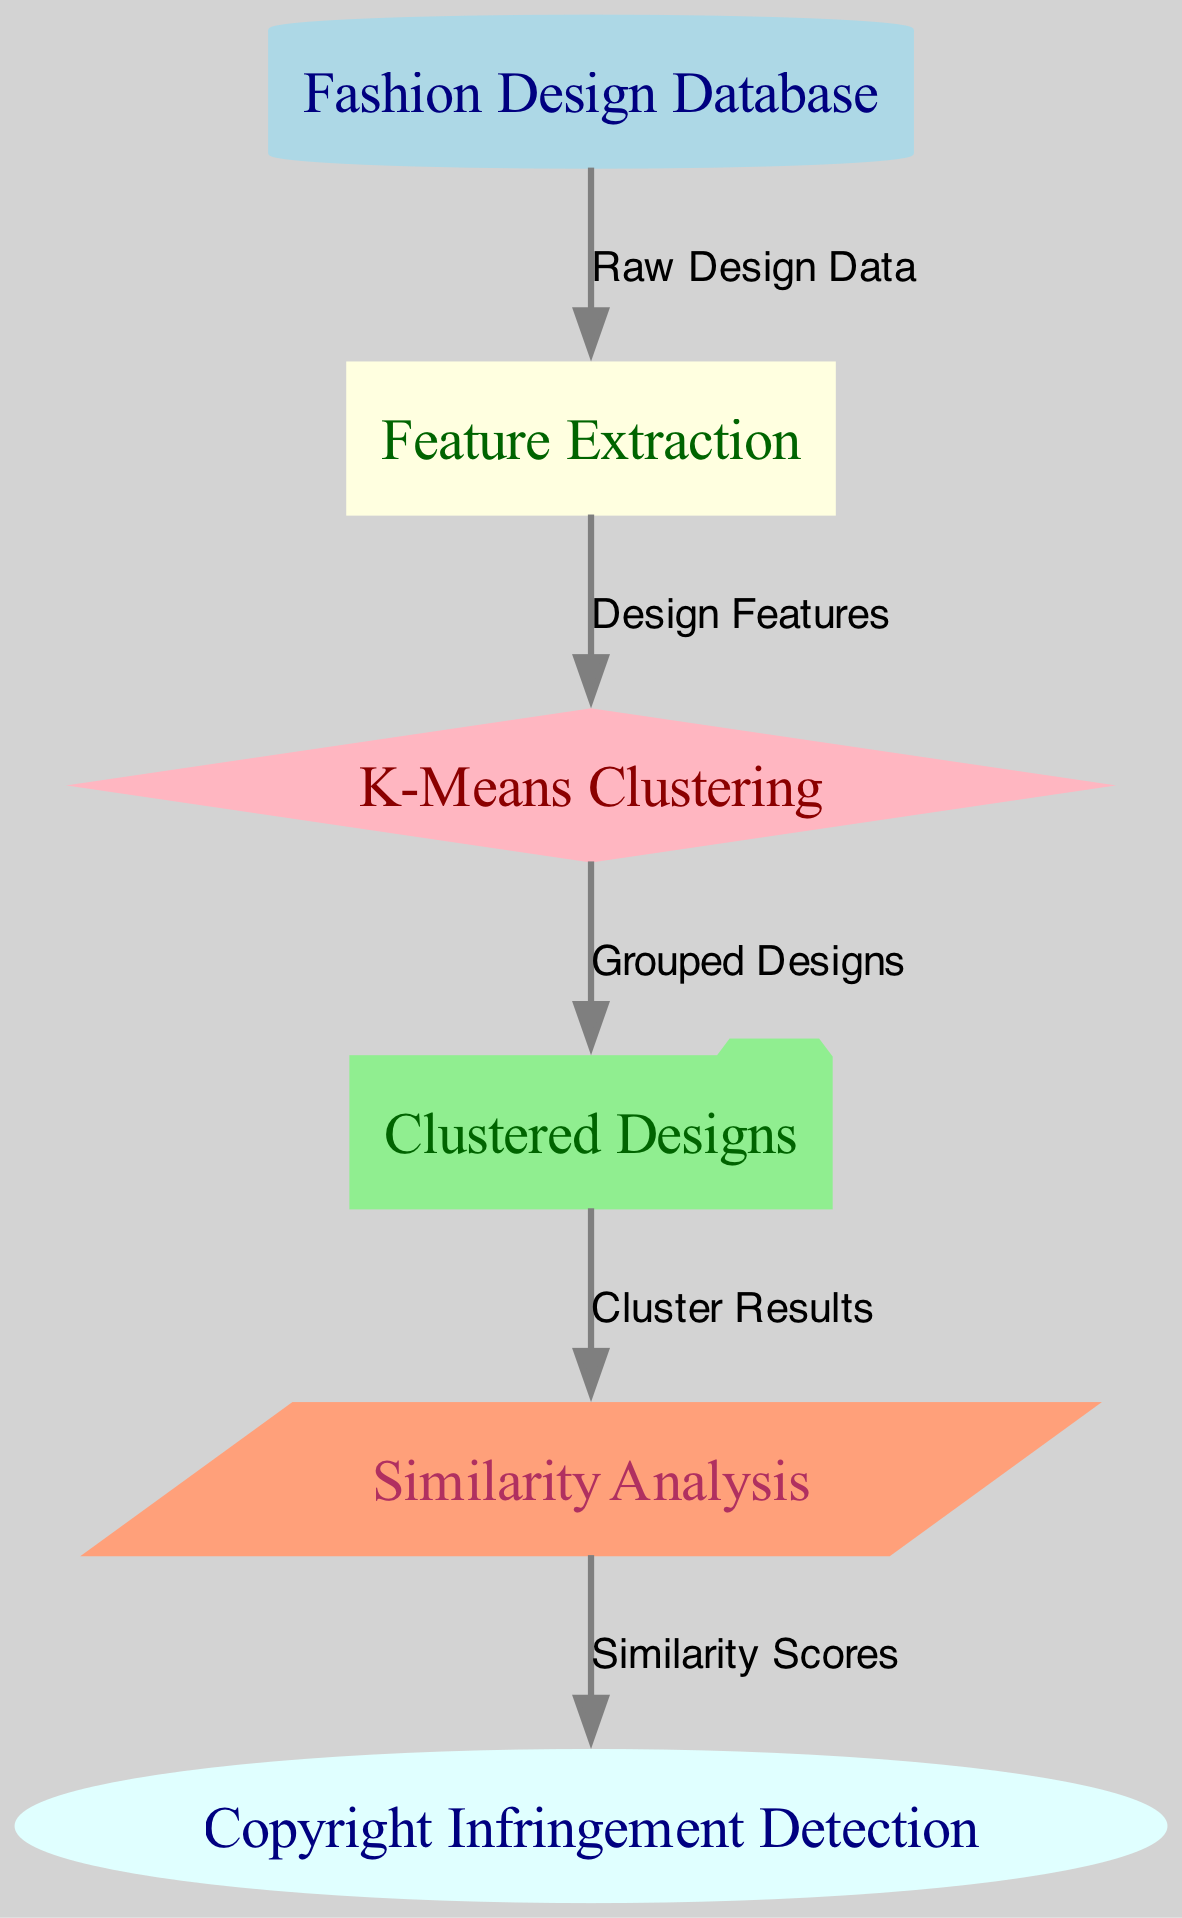What is the first node in the diagram? The first node in the diagram is labeled "Fashion Design Database." It is directly connected to the second node through an edge labeled "Raw Design Data."
Answer: Fashion Design Database How many nodes are in the diagram? The diagram contains a total of six nodes: one input node, one preprocessing node, one algorithm node, one output node, one analysis node, and one legal node.
Answer: Six What is the relationship between the "Feature Extraction" and "K-Means Clustering" nodes? The "Feature Extraction" node processes design features and outputs them to the "K-Means Clustering" node, indicating a direct relationship where the second node depends on the output of the first.
Answer: Design Features What do the edges represent in the diagram? The edges in the diagram represent the flow of data or processes between the different nodes, showing how outputs from one step feed into the next.
Answer: Flow of data Which node follows the "Clustered Designs" node? The node that follows the "Clustered Designs" node is "Similarity Analysis," indicating that the output of the clustering is utilized for further analysis of similarity between designs.
Answer: Similarity Analysis How does "Similarity Analysis" contribute to "Copyright Infringement Detection"? "Similarity Analysis" provides similarity scores that are critical for identifying potential copyright infringements by comparing clustered designs against one another. This step is essential as it translates raw analysis into meaningful legal implications.
Answer: Similarity Scores In the context of this diagram, what is the purpose of the "K-Means Clustering" algorithm? The purpose of the "K-Means Clustering" algorithm is to group similar fashion designs together, enabling a clearer understanding of design similarities for potential legal concerns regarding copyright.
Answer: Grouping similar designs What process occurs before "K-Means Clustering" in the workflow? The process that occurs before "K-Means Clustering" is "Feature Extraction," which transforms raw data into usable design features needed for the clustering algorithm to function effectively.
Answer: Feature Extraction 